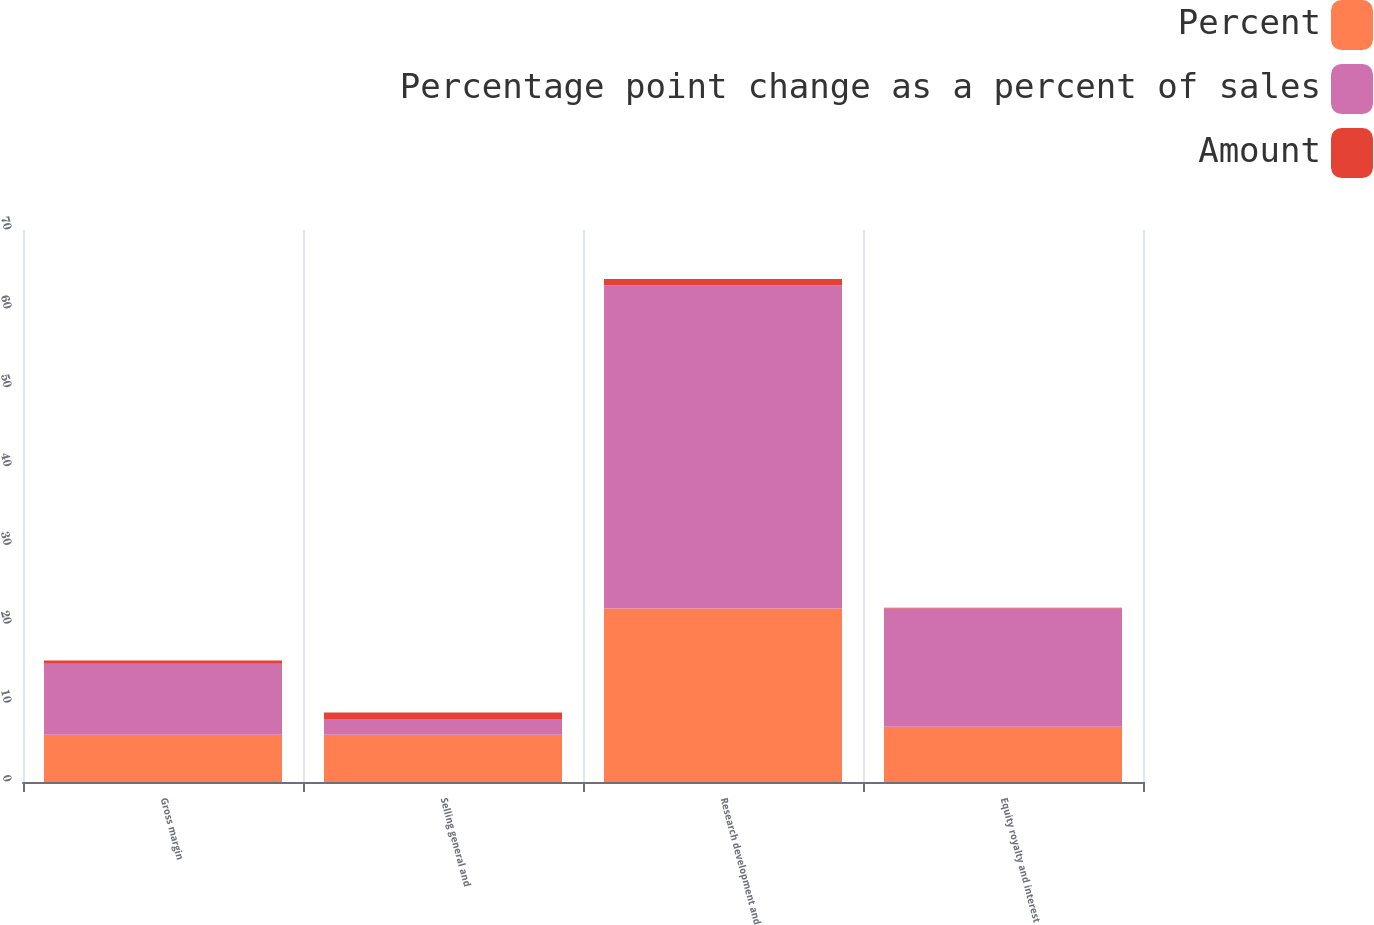Convert chart. <chart><loc_0><loc_0><loc_500><loc_500><stacked_bar_chart><ecel><fcel>Gross margin<fcel>Selling general and<fcel>Research development and<fcel>Equity royalty and interest<nl><fcel>Percent<fcel>6<fcel>6<fcel>22<fcel>7<nl><fcel>Percentage point change as a percent of sales<fcel>9<fcel>2<fcel>41<fcel>15<nl><fcel>Amount<fcel>0.4<fcel>0.8<fcel>0.8<fcel>0.1<nl></chart> 